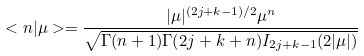Convert formula to latex. <formula><loc_0><loc_0><loc_500><loc_500>< n | \mu > = \frac { | \mu | ^ { ( 2 j + k - 1 ) / 2 } \mu ^ { n } } { \sqrt { \Gamma ( n + 1 ) \Gamma ( 2 j + k + n ) I _ { 2 j + k - 1 } ( 2 | \mu | ) } }</formula> 